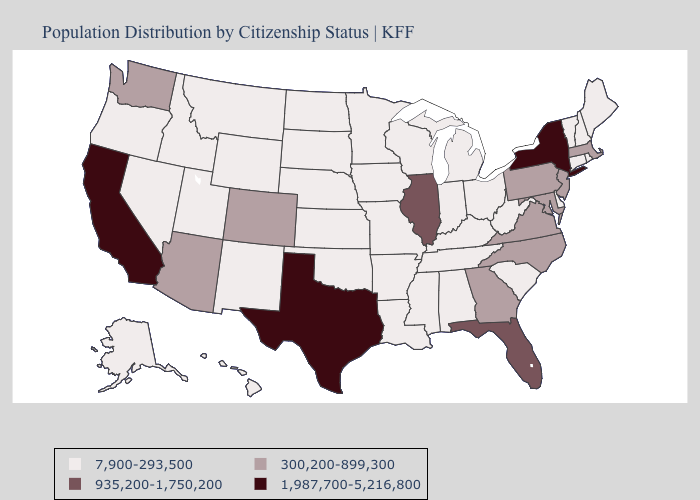Name the states that have a value in the range 935,200-1,750,200?
Short answer required. Florida, Illinois. Among the states that border Iowa , which have the lowest value?
Give a very brief answer. Minnesota, Missouri, Nebraska, South Dakota, Wisconsin. Does Washington have a lower value than Georgia?
Short answer required. No. Name the states that have a value in the range 1,987,700-5,216,800?
Quick response, please. California, New York, Texas. What is the highest value in states that border Oregon?
Answer briefly. 1,987,700-5,216,800. How many symbols are there in the legend?
Keep it brief. 4. What is the value of South Carolina?
Write a very short answer. 7,900-293,500. Is the legend a continuous bar?
Short answer required. No. What is the lowest value in the West?
Give a very brief answer. 7,900-293,500. Which states have the lowest value in the Northeast?
Give a very brief answer. Connecticut, Maine, New Hampshire, Rhode Island, Vermont. Name the states that have a value in the range 1,987,700-5,216,800?
Give a very brief answer. California, New York, Texas. Does the first symbol in the legend represent the smallest category?
Quick response, please. Yes. Does Ohio have the highest value in the MidWest?
Write a very short answer. No. How many symbols are there in the legend?
Write a very short answer. 4. Which states have the highest value in the USA?
Keep it brief. California, New York, Texas. 